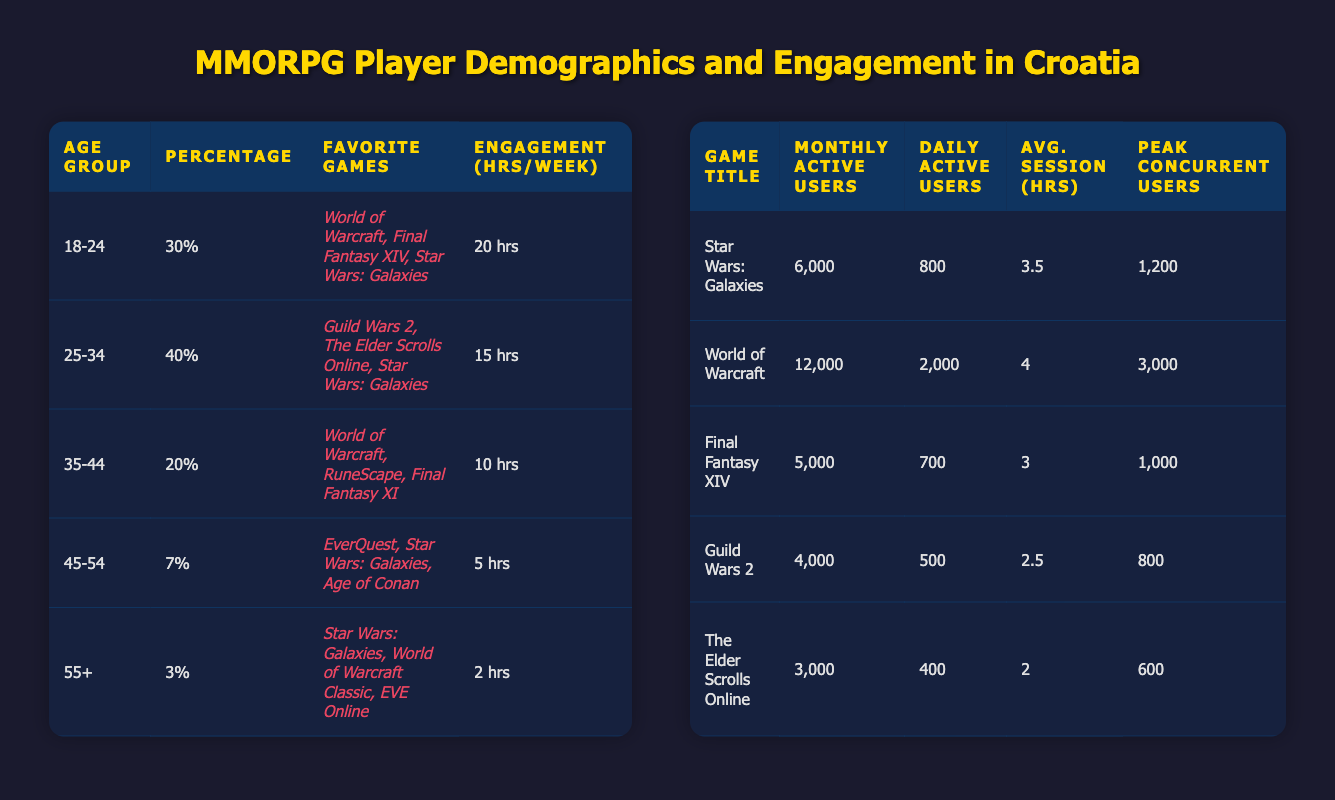What is the percentage of players aged 18-24 in Croatia? The table shows that in the Age Group column, the row for 18-24 years displays a percentage of 30.
Answer: 30 Which age group has the highest engagement hours per week? By inspecting the Engagement (hrs/week) column, the row for the age group 18-24 shows 20 hours, which is higher than any other age group's engagement hours listed in the table.
Answer: 18-24 What is the average number of monthly active users for the games listed? The monthly active users from the games are: 6000 (Star Wars: Galaxies), 12000 (World of Warcraft), 5000 (Final Fantasy XIV), 4000 (Guild Wars 2), and 3000 (The Elder Scrolls Online). Adding them gives 6000 + 12000 + 5000 + 4000 + 3000 = 30000. There are 5 games, so the average is 30000 / 5 = 6000.
Answer: 6000 Are there more monthly active users for World of Warcraft than Star Wars: Galaxies? The table shows World of Warcraft has 12000 monthly active users, while Star Wars: Galaxies has 6000. Since 12000 is greater than 6000, the answer is yes.
Answer: Yes How many daily active users does Final Fantasy XIV have? The row for Final Fantasy XIV displays 700 daily active users in the Daily Active Users column.
Answer: 700 What is the total percentage of players aged 35 and older in Croatia? To find this percentage, add the percentages of the age groups 35-44 (20), 45-54 (7), and 55+ (3). This equals 20 + 7 + 3 = 30.
Answer: 30 Which game has the highest peak concurrent users? Referring to the Peak Concurrent Users column, World of Warcraft shows 3000, which is higher than any other game listed.
Answer: World of Warcraft What is the difference in engagement hours per week between the age groups 25-34 and 45-54? The engagement hours for 25-34 is 15, while for 45-54 it is 5. The difference is calculated as 15 - 5 = 10.
Answer: 10 Is the average session duration for Guild Wars 2 longer than for The Elder Scrolls Online? The table shows that Guild Wars 2 has an average session duration of 2.5 hours, while The Elder Scrolls Online has 2 hours. Since 2.5 is greater than 2, the answer is yes.
Answer: Yes 